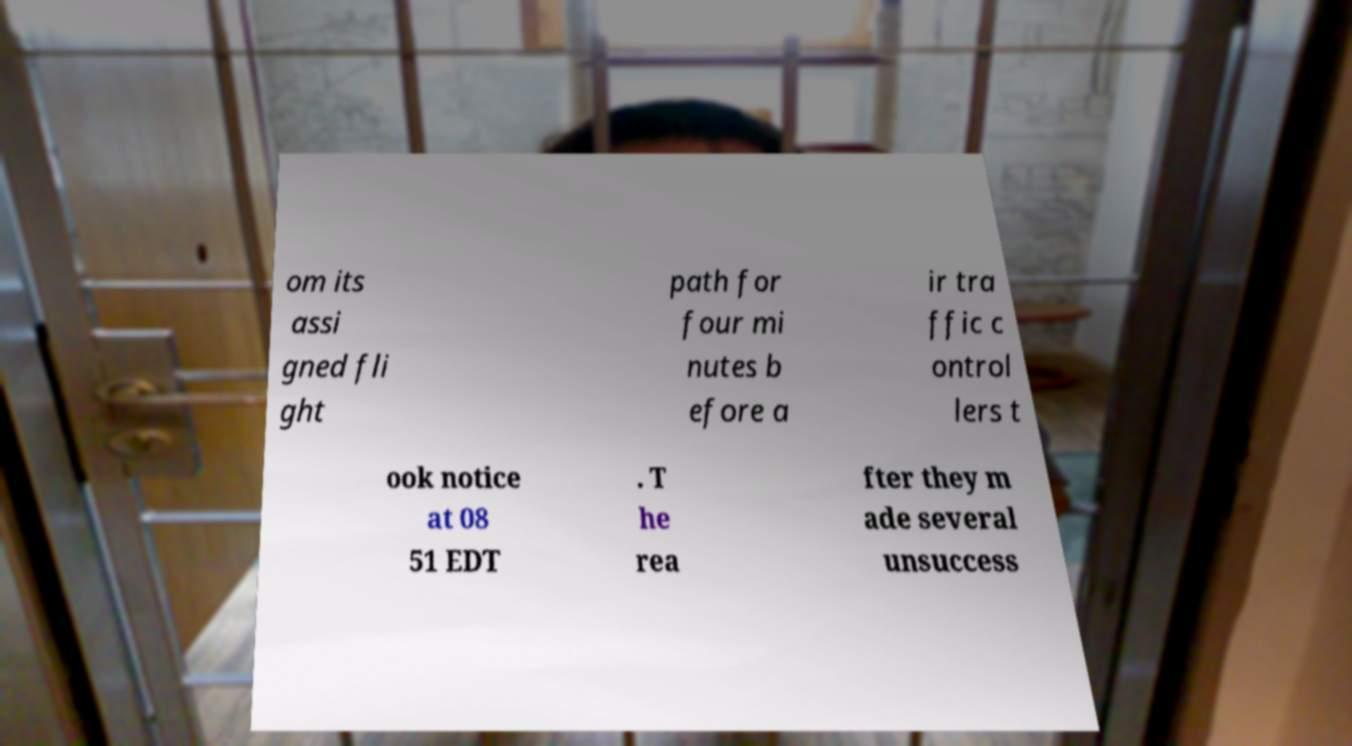For documentation purposes, I need the text within this image transcribed. Could you provide that? om its assi gned fli ght path for four mi nutes b efore a ir tra ffic c ontrol lers t ook notice at 08 51 EDT . T he rea fter they m ade several unsuccess 